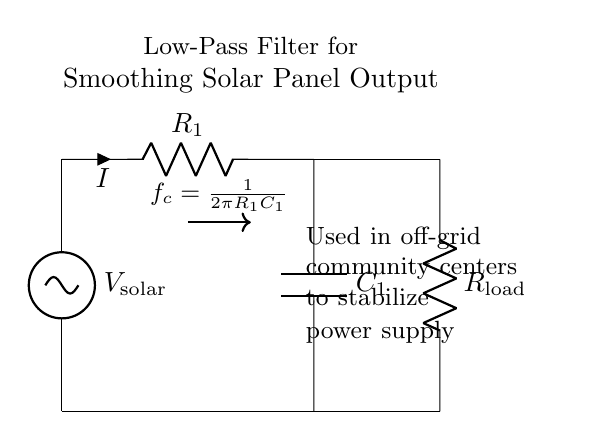What is the type of voltage source in this circuit? The voltage source is labeled as V_solar, indicating it is a solar panel providing DC voltage.
Answer: V_solar What component is located between the voltage source and the load resistor? The resistor labeled R_1 is the component located between the voltage source and the load resistor, controlling current flow.
Answer: R_1 What is the function of the capacitor in this circuit? The capacitor, labeled C_1, serves to smooth out voltage fluctuations from the solar panel, thereby stabilizing the output.
Answer: Smoothing What does the formula given in the diagram represent? The formula f_c = 1/(2πR_1C_1) represents the cutoff frequency of the low-pass filter, relating the resistor and capacitor values.
Answer: Cutoff frequency Which component directly receives current from the solar panel? The load resistor, labeled R_load, directly receives current from the circuit path after the capacitor.
Answer: R_load What is the overall purpose of this circuit? The overall purpose of the circuit is to stabilize the output power from the solar panel for use in off-grid community centers.
Answer: Stabilize power supply 